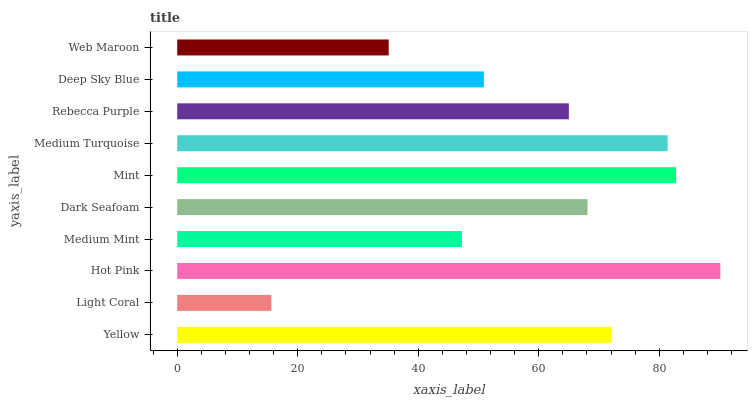Is Light Coral the minimum?
Answer yes or no. Yes. Is Hot Pink the maximum?
Answer yes or no. Yes. Is Hot Pink the minimum?
Answer yes or no. No. Is Light Coral the maximum?
Answer yes or no. No. Is Hot Pink greater than Light Coral?
Answer yes or no. Yes. Is Light Coral less than Hot Pink?
Answer yes or no. Yes. Is Light Coral greater than Hot Pink?
Answer yes or no. No. Is Hot Pink less than Light Coral?
Answer yes or no. No. Is Dark Seafoam the high median?
Answer yes or no. Yes. Is Rebecca Purple the low median?
Answer yes or no. Yes. Is Medium Turquoise the high median?
Answer yes or no. No. Is Medium Mint the low median?
Answer yes or no. No. 